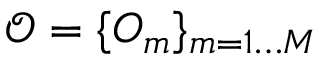<formula> <loc_0><loc_0><loc_500><loc_500>\mathcal { O } = \{ O _ { m } \} _ { m = 1 \dots M }</formula> 